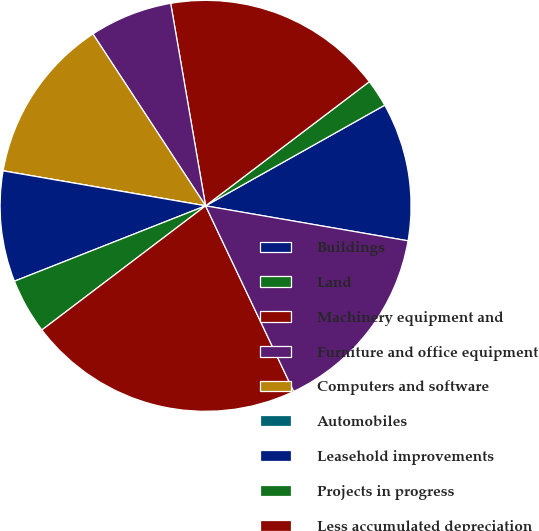<chart> <loc_0><loc_0><loc_500><loc_500><pie_chart><fcel>Buildings<fcel>Land<fcel>Machinery equipment and<fcel>Furniture and office equipment<fcel>Computers and software<fcel>Automobiles<fcel>Leasehold improvements<fcel>Projects in progress<fcel>Less accumulated depreciation<fcel>Net property and equipment<nl><fcel>10.87%<fcel>2.18%<fcel>17.39%<fcel>6.52%<fcel>13.04%<fcel>0.0%<fcel>8.7%<fcel>4.35%<fcel>21.73%<fcel>15.22%<nl></chart> 